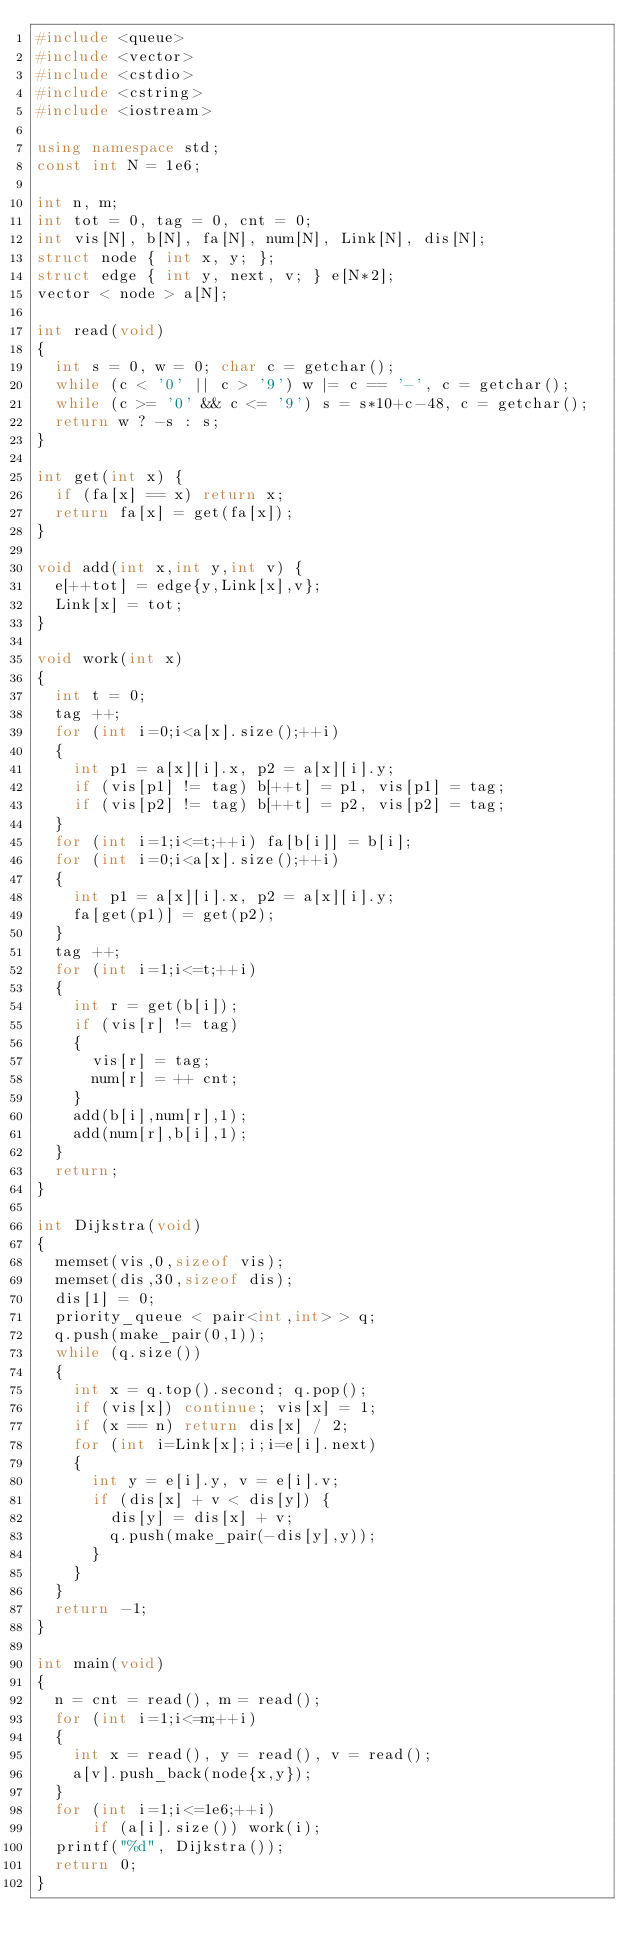Convert code to text. <code><loc_0><loc_0><loc_500><loc_500><_C++_>#include <queue>
#include <vector>
#include <cstdio>
#include <cstring>
#include <iostream>

using namespace std;
const int N = 1e6;

int n, m;
int tot = 0, tag = 0, cnt = 0;
int vis[N], b[N], fa[N], num[N], Link[N], dis[N]; 
struct node { int x, y; }; 
struct edge { int y, next, v; } e[N*2];
vector < node > a[N];

int read(void)
{
	int s = 0, w = 0; char c = getchar();
	while (c < '0' || c > '9') w |= c == '-', c = getchar();
	while (c >= '0' && c <= '9') s = s*10+c-48, c = getchar();
	return w ? -s : s;
}

int get(int x) {
	if (fa[x] == x) return x;
	return fa[x] = get(fa[x]);
}

void add(int x,int y,int v) {
	e[++tot] = edge{y,Link[x],v};
	Link[x] = tot;
}

void work(int x)
{
	int t = 0;
	tag ++;
	for (int i=0;i<a[x].size();++i)
	{
		int p1 = a[x][i].x, p2 = a[x][i].y;
		if (vis[p1] != tag) b[++t] = p1, vis[p1] = tag;
		if (vis[p2] != tag) b[++t] = p2, vis[p2] = tag;
	}
	for (int i=1;i<=t;++i) fa[b[i]] = b[i];
	for (int i=0;i<a[x].size();++i) 
	{
		int p1 = a[x][i].x, p2 = a[x][i].y;
		fa[get(p1)] = get(p2);
	}
	tag ++;
	for (int i=1;i<=t;++i)
	{
		int r = get(b[i]);
		if (vis[r] != tag) 
		{
			vis[r] = tag;
			num[r] = ++ cnt;
		}
		add(b[i],num[r],1);
		add(num[r],b[i],1);
	}
	return;
}

int Dijkstra(void)
{
	memset(vis,0,sizeof vis);
	memset(dis,30,sizeof dis);
	dis[1] = 0;
	priority_queue < pair<int,int> > q;
	q.push(make_pair(0,1));
	while (q.size())
	{
		int x = q.top().second; q.pop();
		if (vis[x]) continue; vis[x] = 1;
		if (x == n) return dis[x] / 2; 
		for (int i=Link[x];i;i=e[i].next)
		{
			int y = e[i].y, v = e[i].v;
			if (dis[x] + v < dis[y]) {
				dis[y] = dis[x] + v;
				q.push(make_pair(-dis[y],y));
			}
		}
	}
	return -1;
}

int main(void)
{
	n = cnt = read(), m = read();
	for (int i=1;i<=m;++i)
	{
		int x = read(), y = read(), v = read();
		a[v].push_back(node{x,y});
	}
	for (int i=1;i<=1e6;++i)
	    if (a[i].size()) work(i);
	printf("%d", Dijkstra());
	return 0;
} </code> 